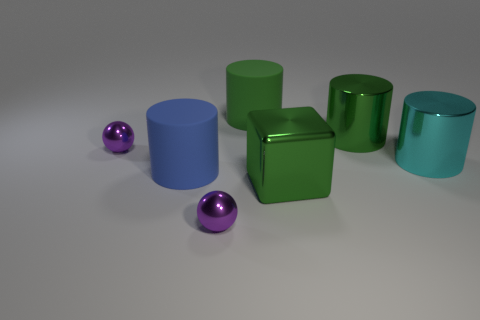How many green cylinders must be subtracted to get 1 green cylinders? 1 Add 1 metallic cylinders. How many objects exist? 8 Subtract all balls. How many objects are left? 5 Subtract all large blue objects. Subtract all green blocks. How many objects are left? 5 Add 7 metal spheres. How many metal spheres are left? 9 Add 7 big matte objects. How many big matte objects exist? 9 Subtract 0 brown spheres. How many objects are left? 7 